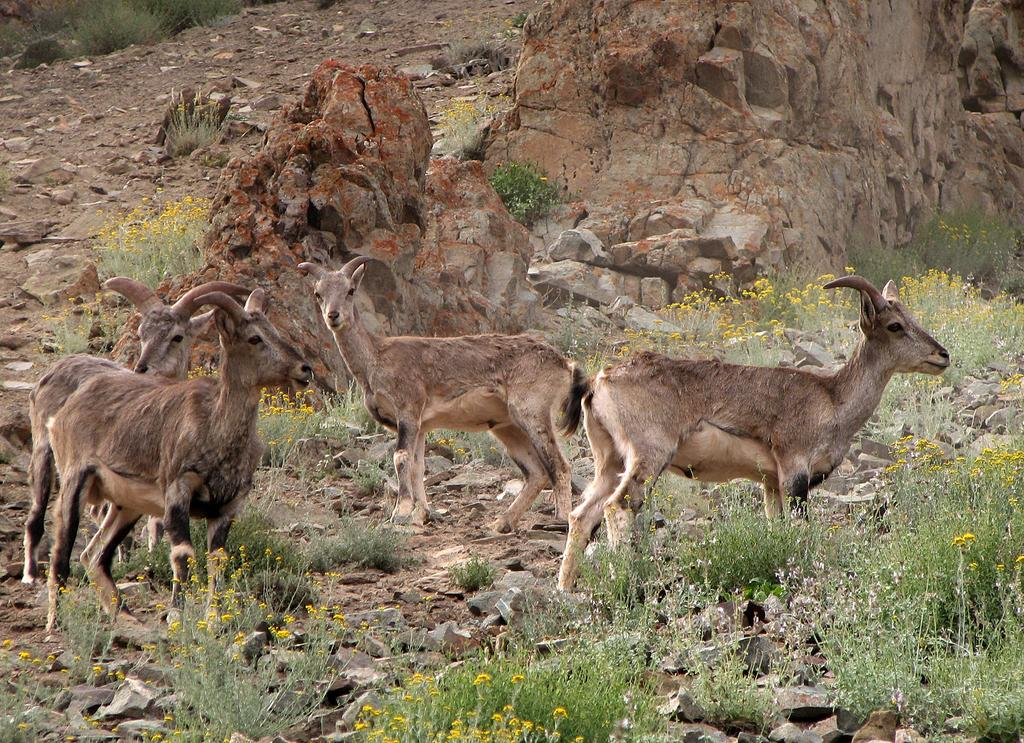What type of living organisms can be seen in the image? There are animals in the image. What type of vegetation is present in the image? There is grass, flowers, and plants in the image. What other natural elements can be seen in the image? There are rocks and stones in the image. Can you tell me how many toes the sheep has in the image? There is no sheep present in the image, and therefore no toes can be counted. What book is the animal reading in the image? There is no animal reading a book in the image. 